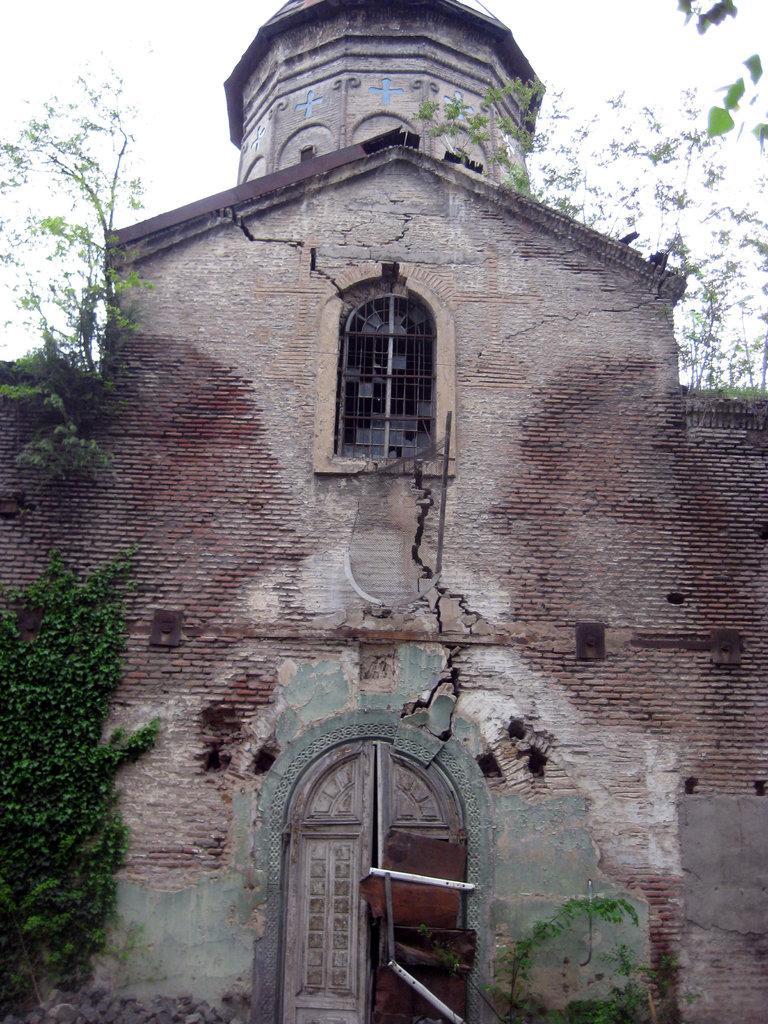What type of structure is present in the image? There is a building in the image. What features can be seen on the building? The building has windows and doors. Are there any visible signs of damage or wear on the building? Yes, there are cracks on the building. What else is present on the building? There are plants on the building. What can be seen in the background of the image? There are trees and the sky visible in the background of the image. What type of surprise can be seen happening at the airport in the image? There is no airport or surprise present in the image; it features a building with windows, doors, cracks, and plants, along with trees and the sky in the background. 